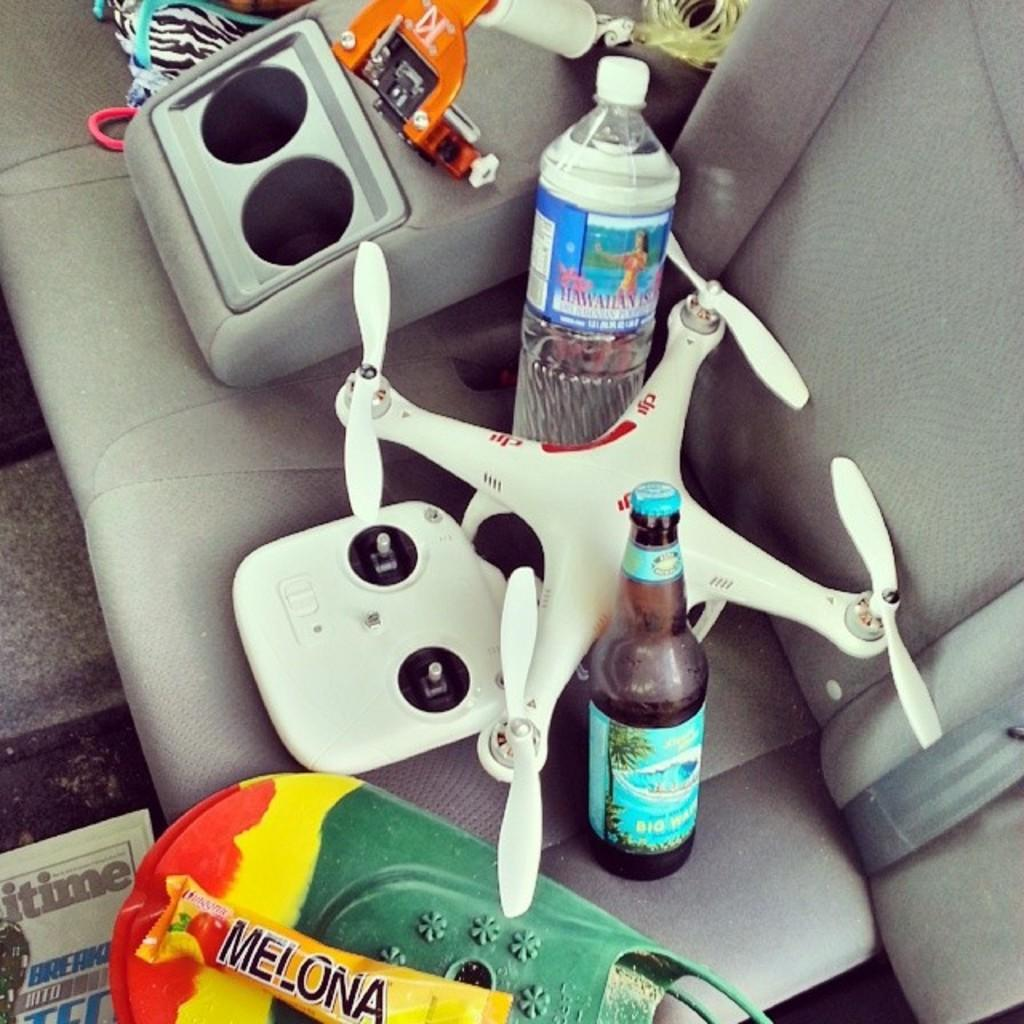<image>
Relay a brief, clear account of the picture shown. The backseat of a vehicle sits Hawaiian Island water and a few other things 